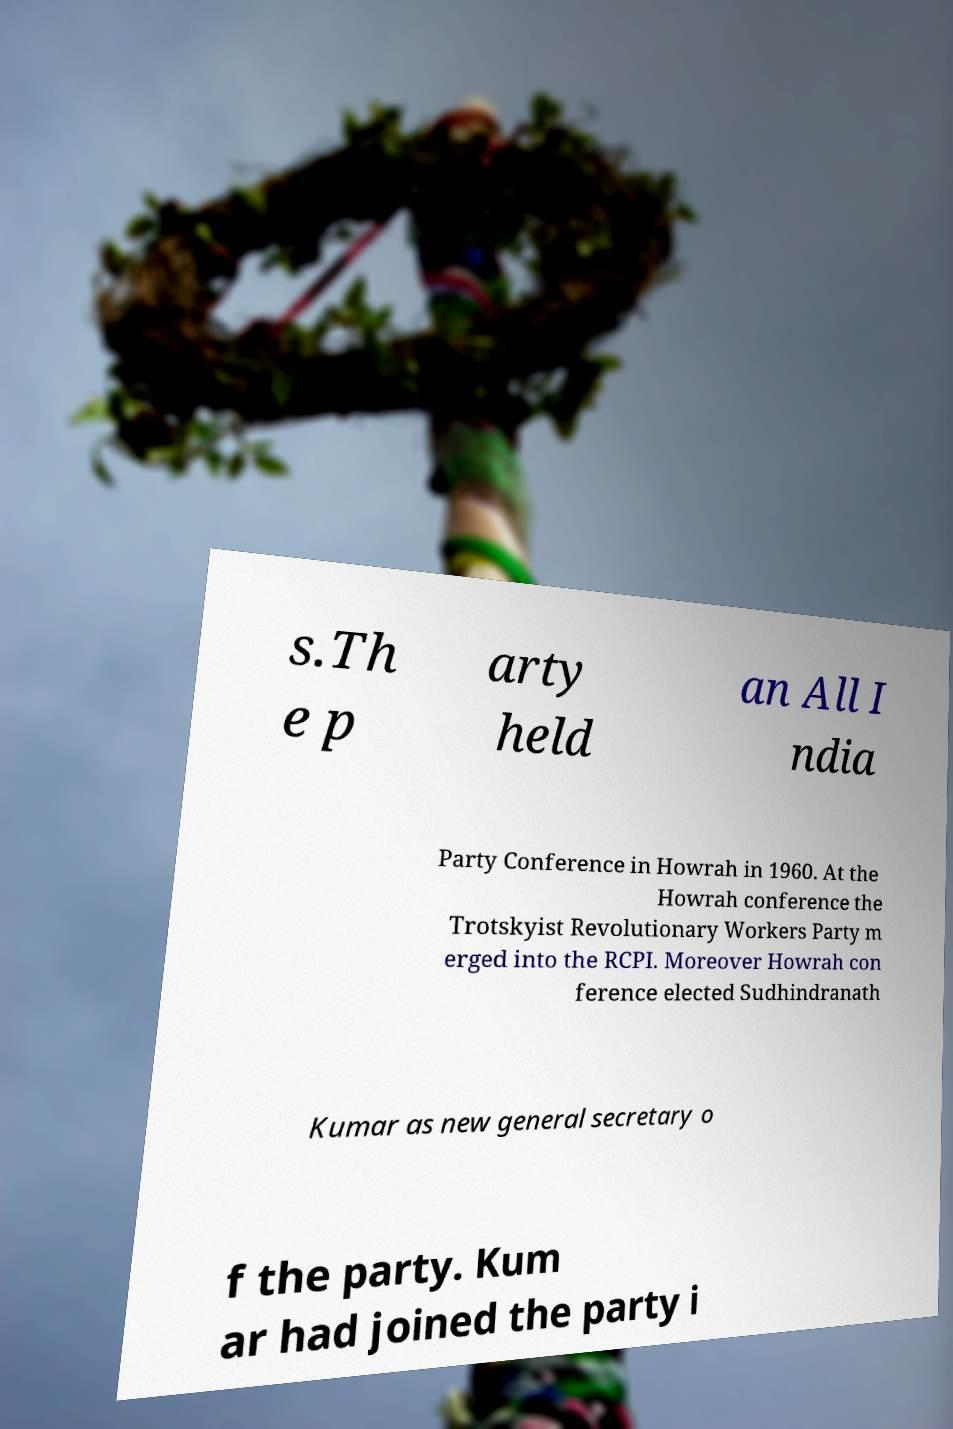What messages or text are displayed in this image? I need them in a readable, typed format. s.Th e p arty held an All I ndia Party Conference in Howrah in 1960. At the Howrah conference the Trotskyist Revolutionary Workers Party m erged into the RCPI. Moreover Howrah con ference elected Sudhindranath Kumar as new general secretary o f the party. Kum ar had joined the party i 